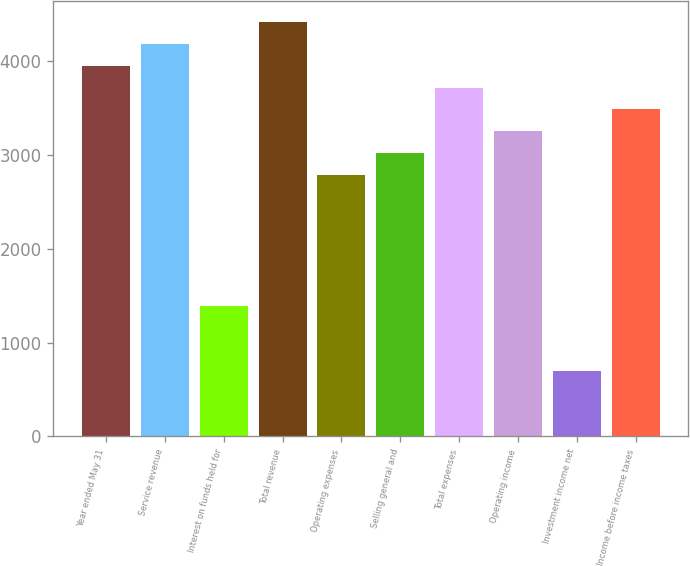Convert chart to OTSL. <chart><loc_0><loc_0><loc_500><loc_500><bar_chart><fcel>Year ended May 31<fcel>Service revenue<fcel>Interest on funds held for<fcel>Total revenue<fcel>Operating expenses<fcel>Selling general and<fcel>Total expenses<fcel>Operating income<fcel>Investment income net<fcel>Income before income taxes<nl><fcel>3953.64<fcel>4186.13<fcel>1396.25<fcel>4418.62<fcel>2791.19<fcel>3023.68<fcel>3721.15<fcel>3256.17<fcel>698.78<fcel>3488.66<nl></chart> 